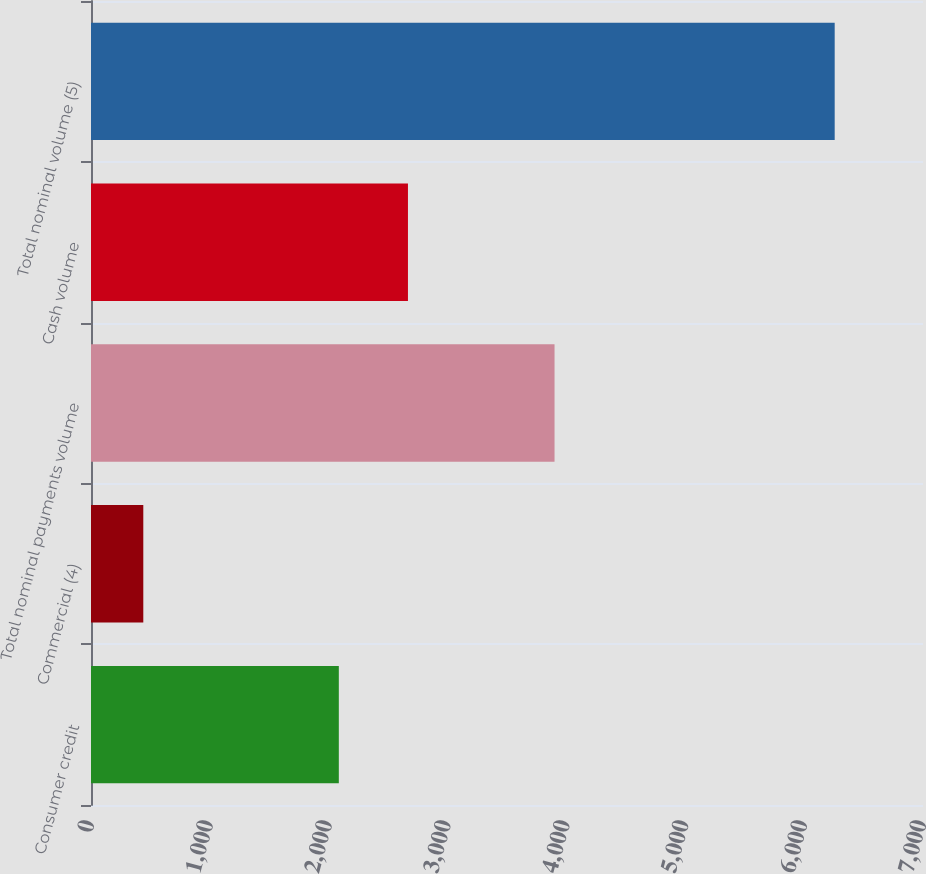Convert chart to OTSL. <chart><loc_0><loc_0><loc_500><loc_500><bar_chart><fcel>Consumer credit<fcel>Commercial (4)<fcel>Total nominal payments volume<fcel>Cash volume<fcel>Total nominal volume (5)<nl><fcel>2085<fcel>440<fcel>3900<fcel>2666.7<fcel>6257<nl></chart> 